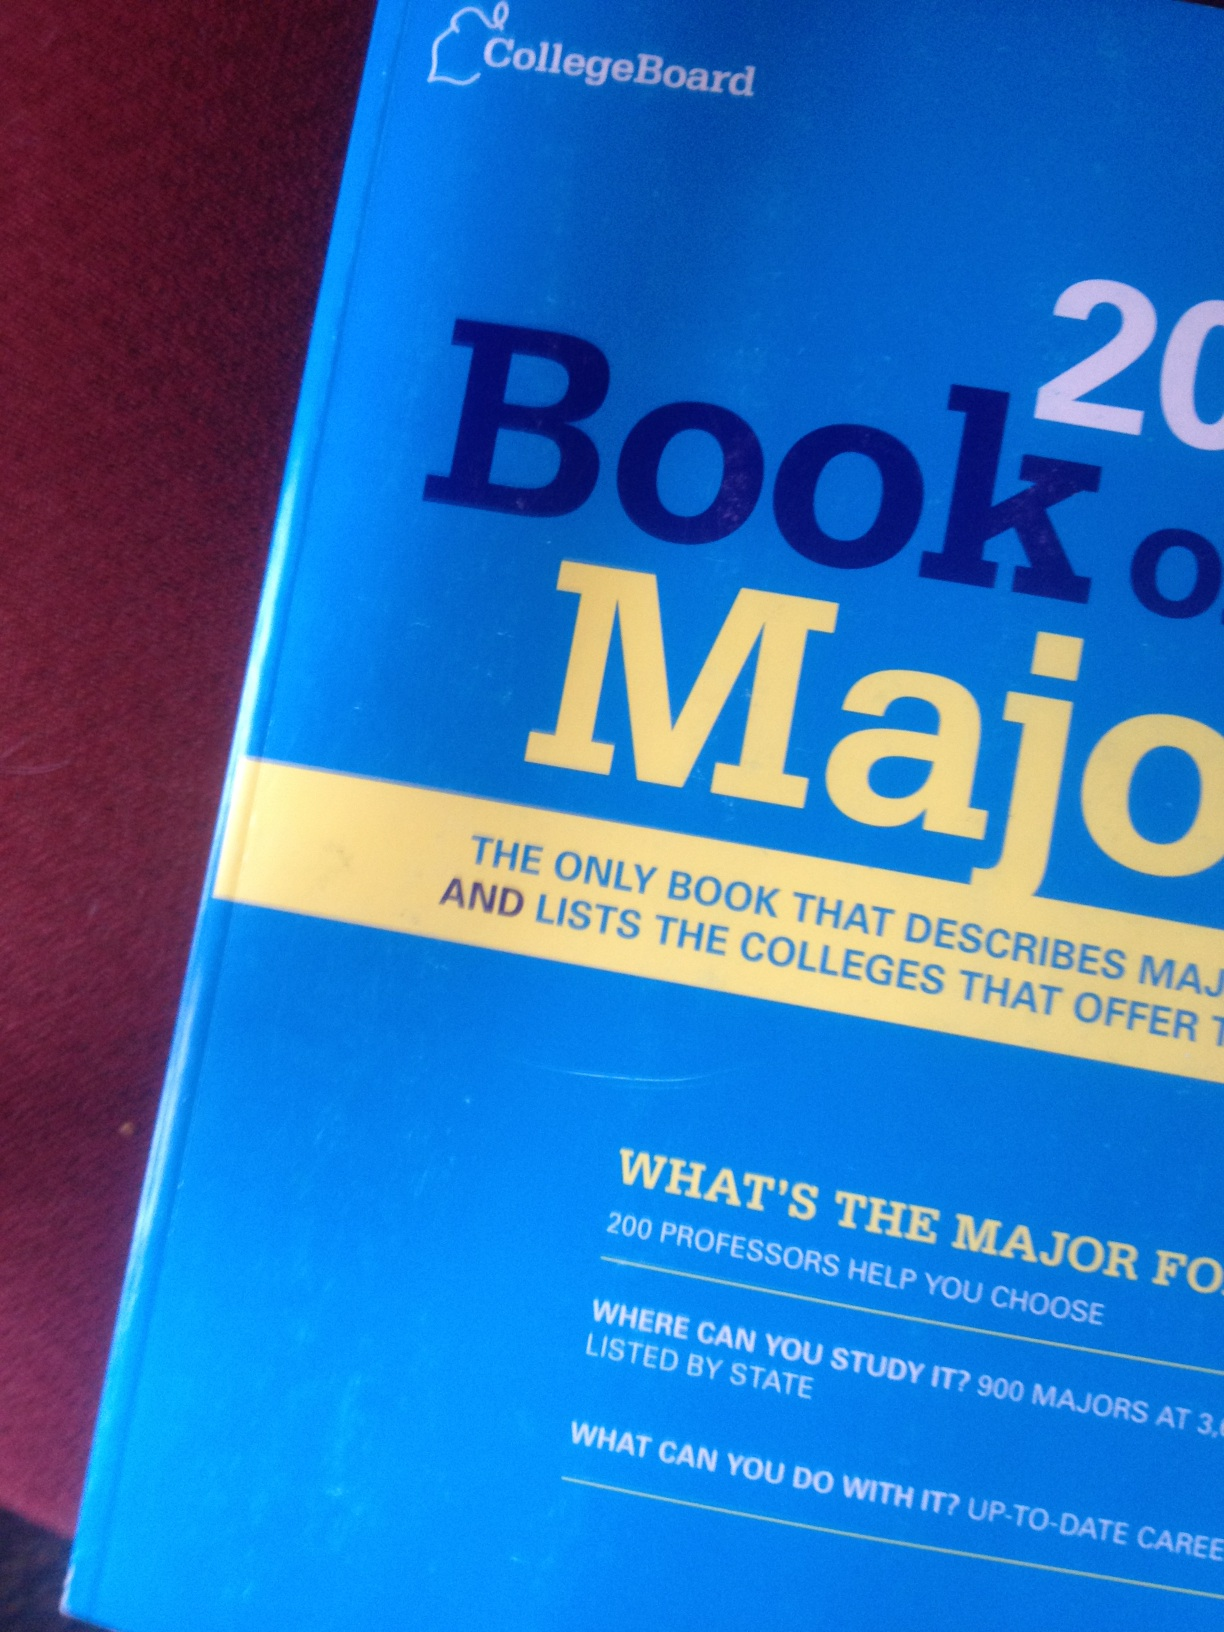How can this book help a student choosing a major? The 'Book of Majors' is designed to assist students by offering a comprehensive overview of available academic majors. It helps students understand the prerequisites, the core study areas, and potential career paths for each major, enabling them to make informed decisions about their educational and career trajectories. What are some unique features of this book that set it apart from other college guides? Unlike generic college guides that only list programs and schools, the 'Book of Majors' dives deep into each subject, with detailed analyses and advice from faculty actively teaching in those fields. It also lists updated, state-wise colleges and universities offering the majors, along with up-to-date career advice reflecting the current job market. 